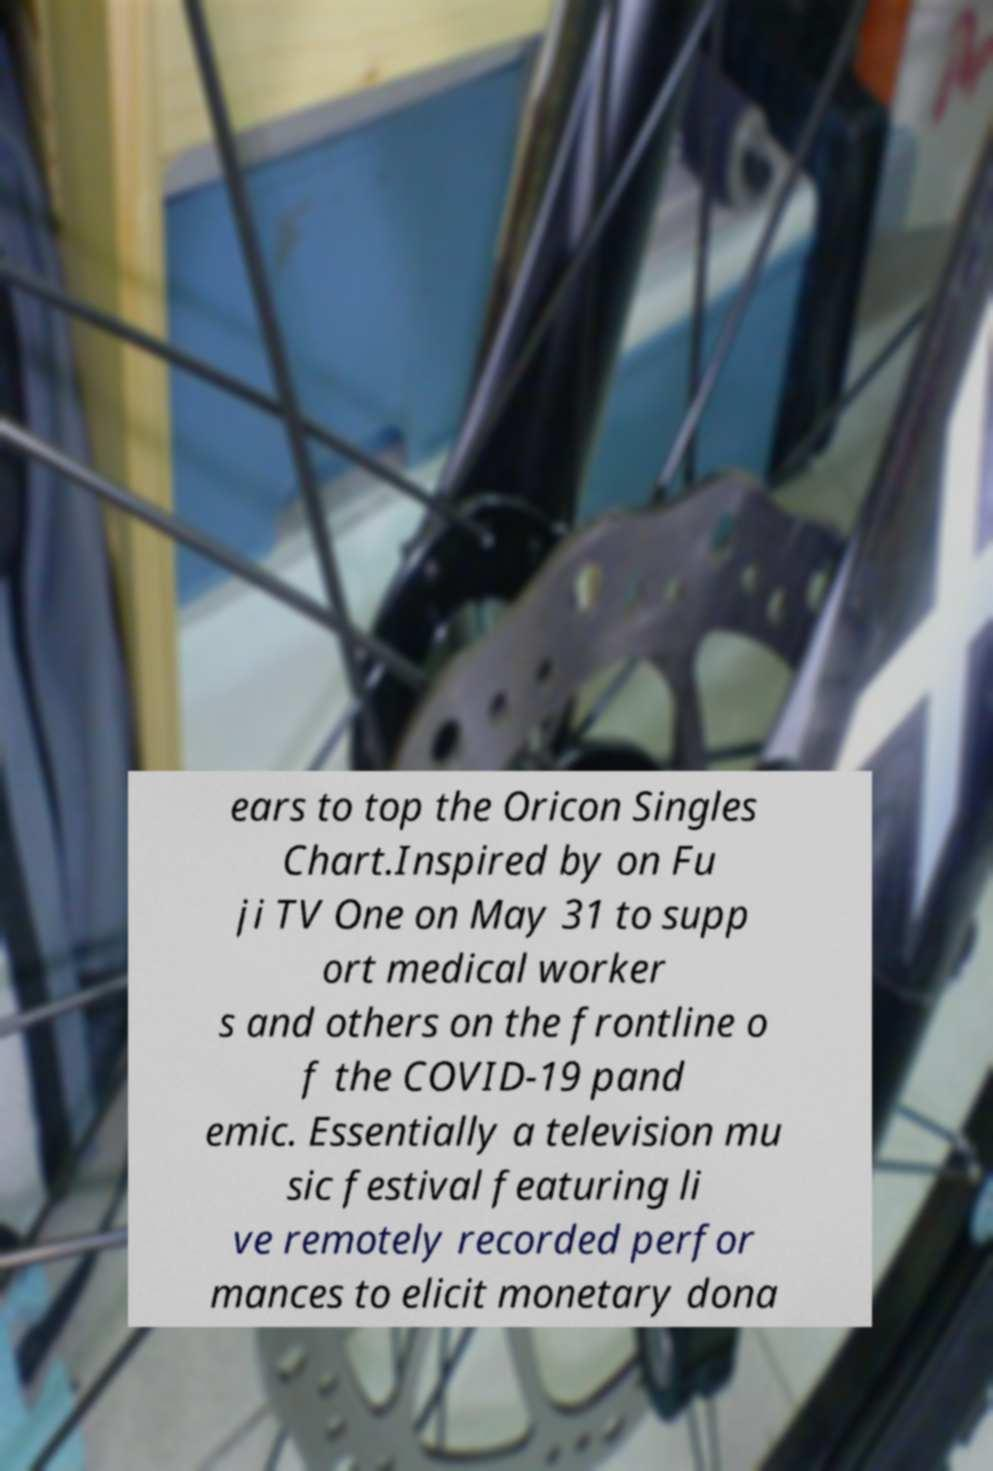Please read and relay the text visible in this image. What does it say? ears to top the Oricon Singles Chart.Inspired by on Fu ji TV One on May 31 to supp ort medical worker s and others on the frontline o f the COVID-19 pand emic. Essentially a television mu sic festival featuring li ve remotely recorded perfor mances to elicit monetary dona 